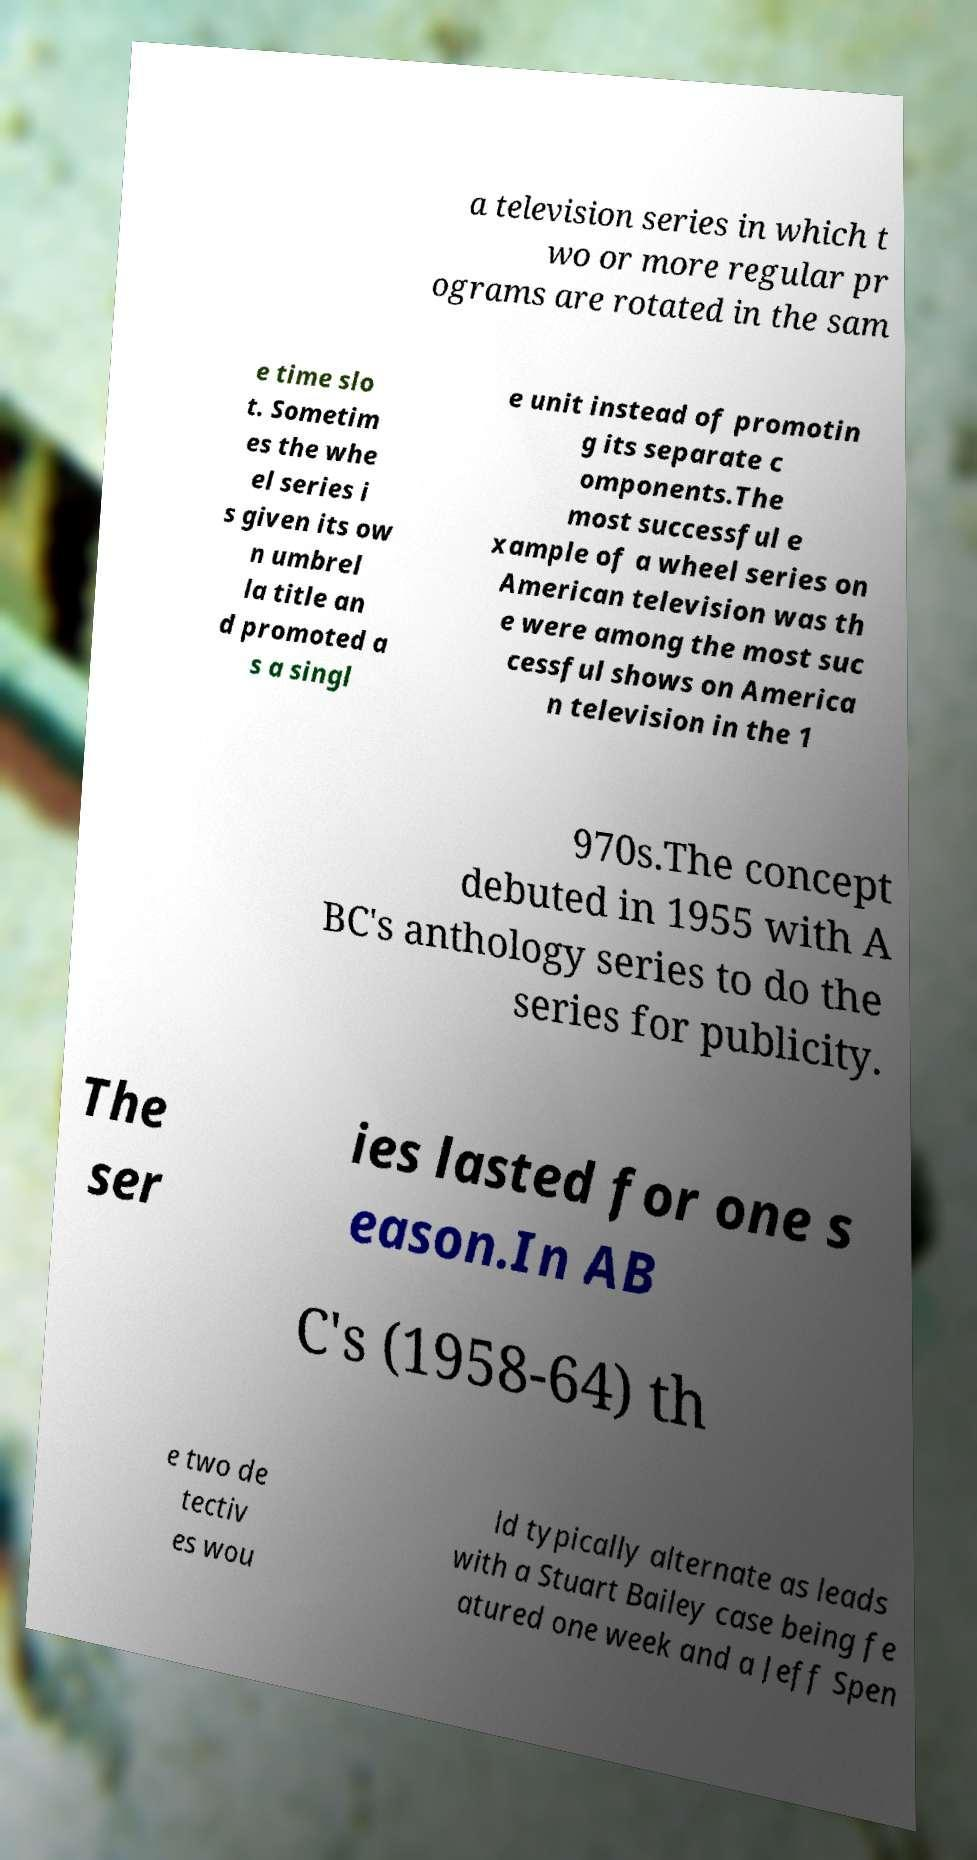Please identify and transcribe the text found in this image. a television series in which t wo or more regular pr ograms are rotated in the sam e time slo t. Sometim es the whe el series i s given its ow n umbrel la title an d promoted a s a singl e unit instead of promotin g its separate c omponents.The most successful e xample of a wheel series on American television was th e were among the most suc cessful shows on America n television in the 1 970s.The concept debuted in 1955 with A BC's anthology series to do the series for publicity. The ser ies lasted for one s eason.In AB C's (1958-64) th e two de tectiv es wou ld typically alternate as leads with a Stuart Bailey case being fe atured one week and a Jeff Spen 